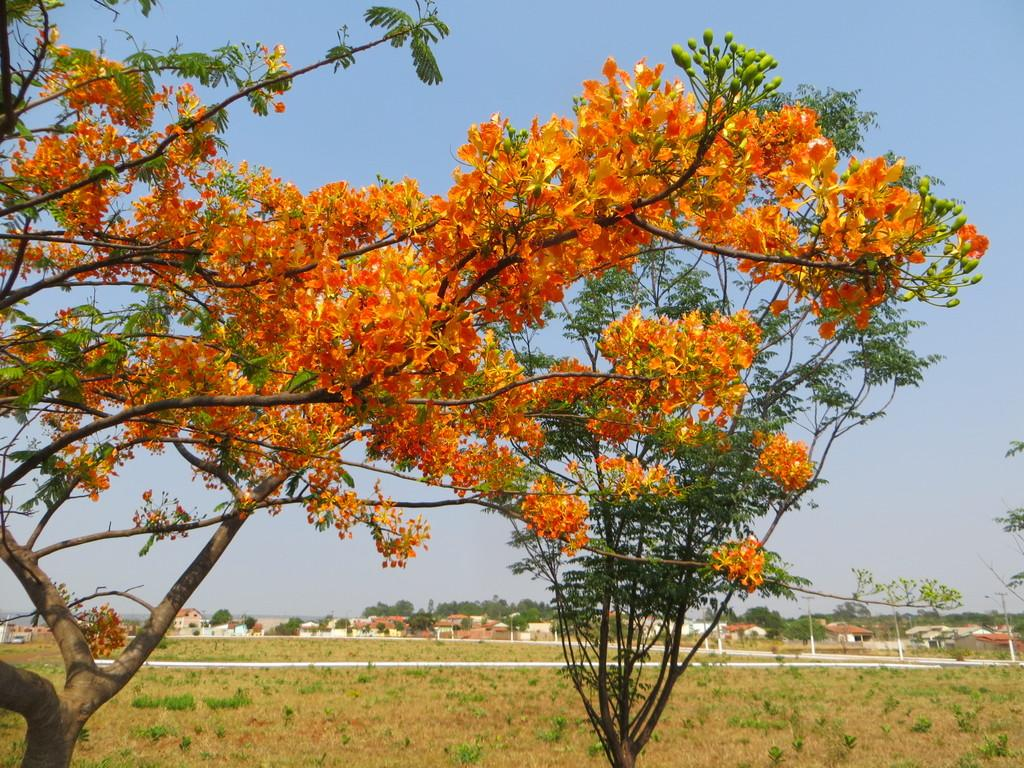What type of vegetation can be seen in the image? There is grass in the image. What type of structures are present in the image? There are buildings in the image. What other natural elements can be seen in the image? There are trees and flowers in the image. What are the poles used for in the image? The purpose of the poles is not specified, but they are visible in the image. What is visible in the background of the image? The sky is visible in the background of the image. What type of thrill can be seen on the rat in the image? There is no rat present in the image, so it is not possible to answer that question. 